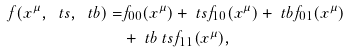Convert formula to latex. <formula><loc_0><loc_0><loc_500><loc_500>f ( x ^ { \mu } , \ t s , \ t b ) = & f _ { 0 0 } ( x ^ { \mu } ) + \ t s f _ { 1 0 } ( x ^ { \mu } ) + \ t b f _ { 0 1 } ( x ^ { \mu } ) \\ & + \ t b \ t s f _ { 1 1 } ( x ^ { \mu } ) ,</formula> 